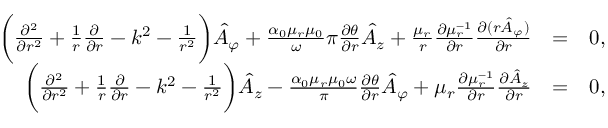Convert formula to latex. <formula><loc_0><loc_0><loc_500><loc_500>\begin{array} { r l r } { \left ( \frac { \partial ^ { 2 } } { \partial r ^ { 2 } } + \frac { 1 } { r } \frac { \partial } { \partial r } - k ^ { 2 } - \frac { 1 } { r ^ { 2 } } \right ) \hat { A } _ { \varphi } + \frac { \alpha _ { 0 } \mu _ { r } \mu _ { 0 } } \omega { \pi } \frac { \partial \theta } { \partial r } \hat { A } _ { z } + \frac { \mu _ { r } } { r } \frac { \partial \mu _ { r } ^ { - 1 } } { \partial r } \frac { \partial ( r \hat { A } _ { \varphi } ) } { \partial r } } & { = } & { 0 , } \\ { \left ( \frac { \partial ^ { 2 } } { \partial r ^ { 2 } } + \frac { 1 } { r } \frac { \partial } { \partial r } - k ^ { 2 } - \frac { 1 } { r ^ { 2 } } \right ) \hat { A } _ { z } - \frac { \alpha _ { 0 } \mu _ { r } \mu _ { 0 } \omega } { \pi } \frac { \partial \theta } { \partial r } \hat { A } _ { \varphi } + \mu _ { r } \frac { \partial \mu _ { r } ^ { - 1 } } { \partial r } \frac { \partial \hat { A } _ { z } } { \partial r } } & { = } & { 0 , } \end{array}</formula> 